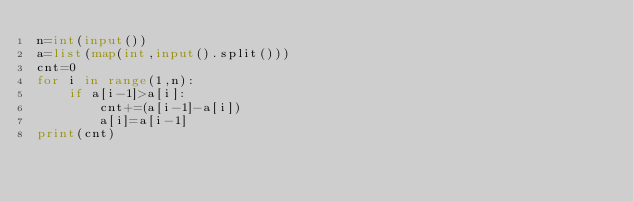<code> <loc_0><loc_0><loc_500><loc_500><_Python_>n=int(input())
a=list(map(int,input().split()))
cnt=0
for i in range(1,n):
    if a[i-1]>a[i]:
        cnt+=(a[i-1]-a[i])
        a[i]=a[i-1]
print(cnt)</code> 